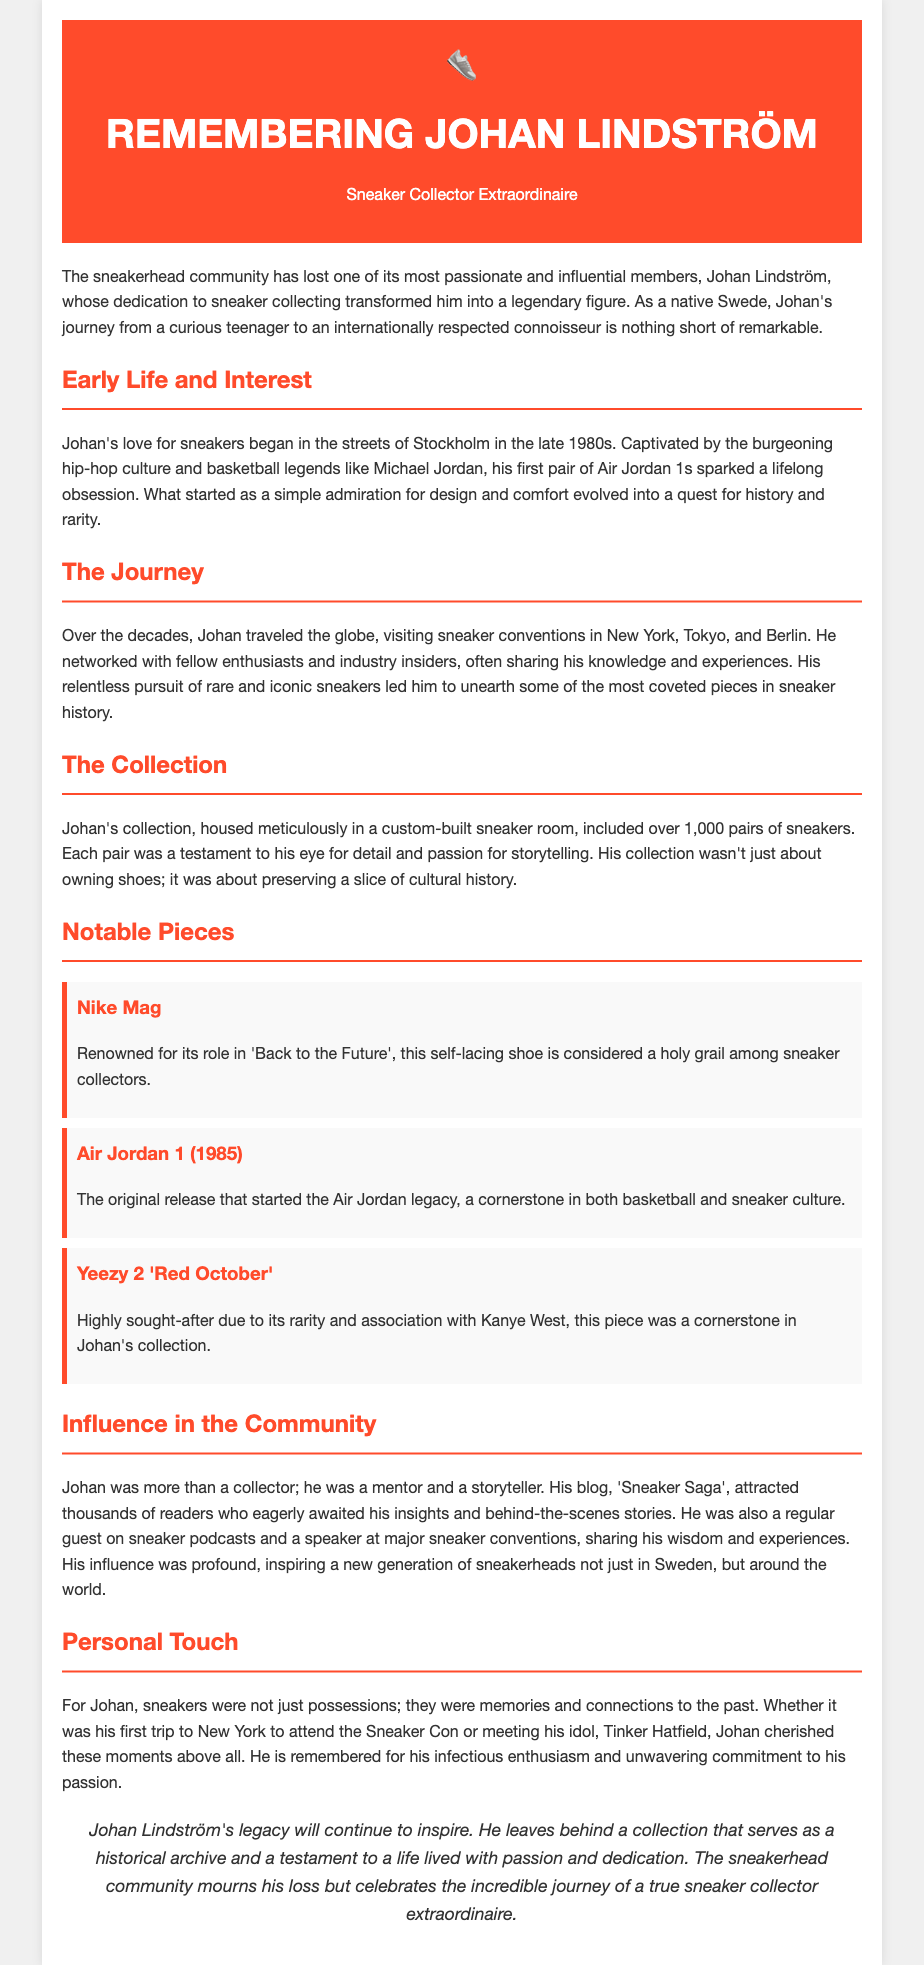what sparked Johan Lindström's love for sneakers? Johan's love for sneakers began with his first pair of Air Jordan 1s.
Answer: Air Jordan 1s how many pairs of sneakers were in Johan's collection? Johan's collection included over 1,000 pairs of sneakers.
Answer: over 1,000 which notable sneaker is renowned for its role in 'Back to the Future'? The Nike Mag is known for its role in 'Back to the Future'.
Answer: Nike Mag who was Johan's idol mentioned in the document? Johan met his idol, Tinker Hatfield.
Answer: Tinker Hatfield what was the name of Johan's blog? Johan's blog was called 'Sneaker Saga'.
Answer: Sneaker Saga what type of shoe is the Yeezy 2 'Red October'? The Yeezy 2 'Red October' is highly sought-after due to its rarity and association with Kanye West.
Answer: highly sought-after what cultural aspect influenced Johan's initial interest in sneakers? Johan was captivated by the burgeoning hip-hop culture.
Answer: hip-hop culture what type of events did Johan frequently attend as part of his sneaker journey? Johan traveled to sneaker conventions.
Answer: sneaker conventions what legacy did Johan Lindström leave behind? Johan's legacy includes a collection that serves as a historical archive.
Answer: historical archive 